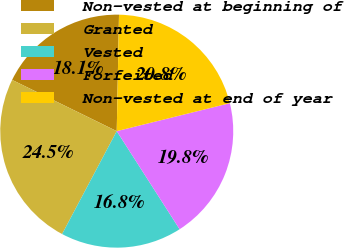Convert chart. <chart><loc_0><loc_0><loc_500><loc_500><pie_chart><fcel>Non-vested at beginning of<fcel>Granted<fcel>Vested<fcel>Forfeited<fcel>Non-vested at end of year<nl><fcel>18.06%<fcel>24.48%<fcel>16.84%<fcel>19.79%<fcel>20.83%<nl></chart> 